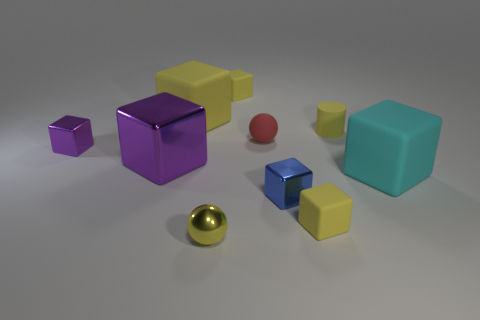There is a cylinder that is the same material as the small red thing; what color is it?
Offer a very short reply. Yellow. Are there any tiny purple spheres that have the same material as the cyan thing?
Make the answer very short. No. What number of objects are either large blue matte balls or purple objects?
Your response must be concise. 2. Are the large yellow object and the big cube to the right of the blue metallic object made of the same material?
Provide a succinct answer. Yes. What is the size of the yellow block in front of the yellow rubber cylinder?
Offer a very short reply. Small. Is the number of objects less than the number of shiny objects?
Offer a terse response. No. Are there any small metal spheres of the same color as the matte ball?
Give a very brief answer. No. What is the shape of the yellow object that is both on the right side of the large yellow object and behind the yellow matte cylinder?
Make the answer very short. Cube. The tiny yellow object that is in front of the yellow matte object that is in front of the big cyan matte cube is what shape?
Make the answer very short. Sphere. Do the blue object and the tiny red rubber thing have the same shape?
Your response must be concise. No. 